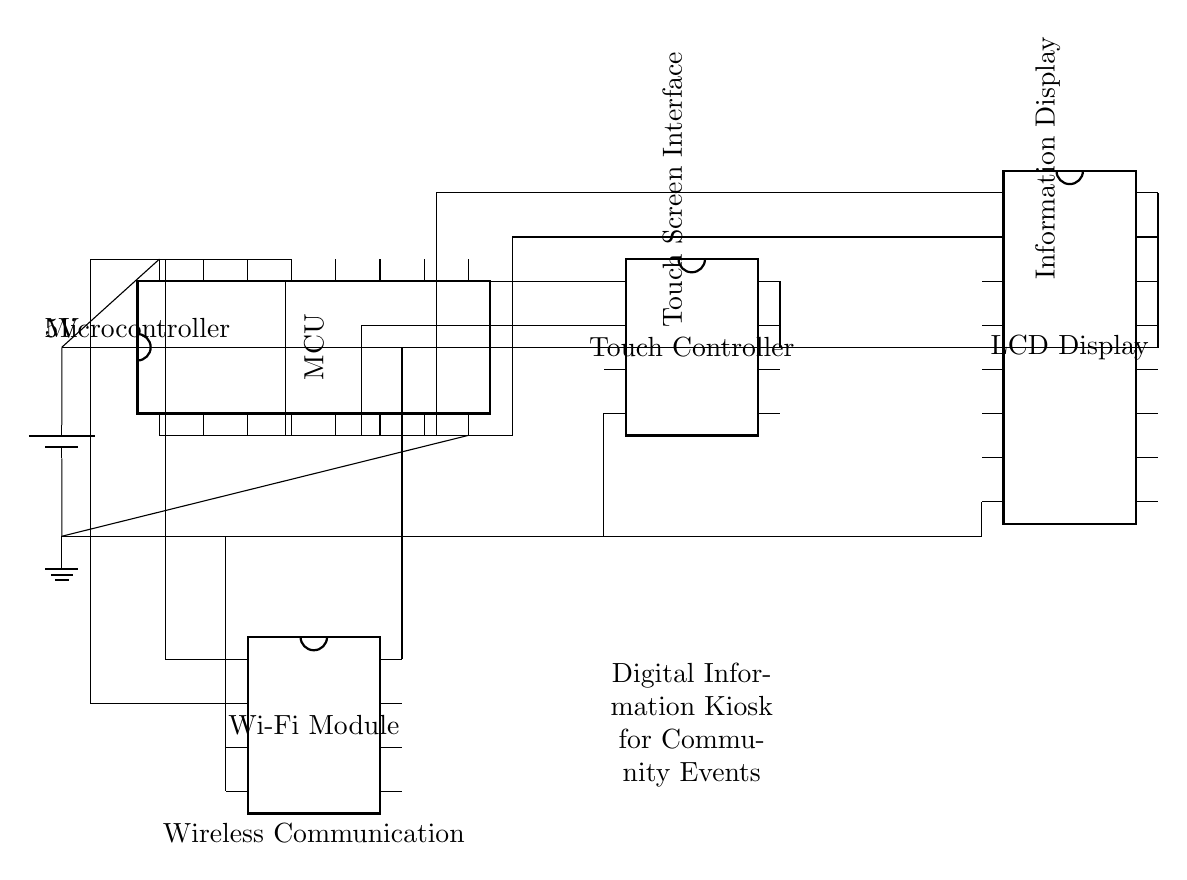What is the main component of this circuit? The main component is the Microcontroller, which is identified by the label "MCU" in the circuit diagram. It serves as the central unit that processes information and controls the other components.
Answer: Microcontroller How many pins does the LCD Display have? The LCD Display, indicated in the circuit diagram, has 16 pins as shown by the number next to it. This indicates the number of electrical connections provided to interface with the Microcontroller.
Answer: 16 What type of communication does this circuit use? The circuit includes a Wi-Fi Module, which is dedicated to wireless communication as indicated in the diagram. This allows the digital kiosk to connect to the internet and communicate with other devices.
Answer: Wireless communication How is the touch screen connected to the Microcontroller? The Touch Controller is connected to the Microcontroller through two connections. The lines from pins 1 and 2 of the Microcontroller lead to the first two pins of the Touch Controller, indicating a direct connection for control and data transmission.
Answer: Two connections What is the power supply voltage for this circuit? The circuit operates at a voltage of 5V, which is indicated by the battery symbol in the diagram. This voltage is necessary for the operation of all components including the Microcontroller, Touch Controller, Display, and Wi-Fi Module.
Answer: 5V What is the purpose of the ground connections in this circuit? Ground connections provide a common reference point for the voltage levels in the circuit. They ensure that all components operate correctly and safely by stabilizing the electrical signals and returning them to a neutral point. In this circuit, all components have ground connections indicated by the ground symbol.
Answer: Common reference point 